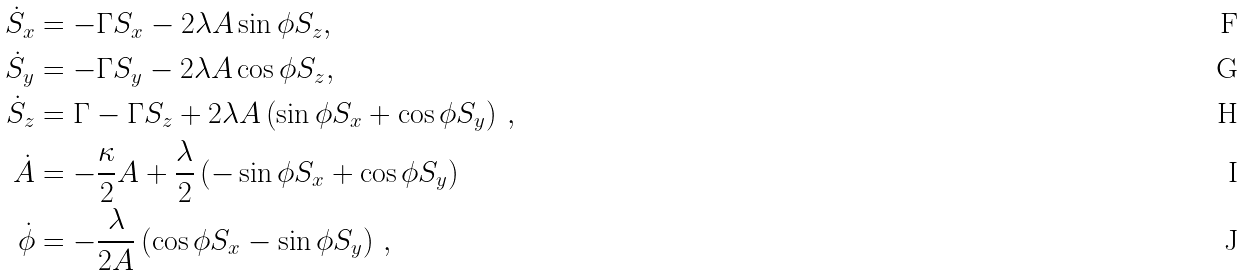<formula> <loc_0><loc_0><loc_500><loc_500>\dot { S } _ { x } & = - \Gamma S _ { x } - 2 \lambda A \sin \phi S _ { z } , \\ \dot { S } _ { y } & = - \Gamma S _ { y } - 2 \lambda A \cos \phi S _ { z } , \\ \dot { S } _ { z } & = \Gamma - \Gamma S _ { z } + 2 \lambda A \left ( \sin \phi S _ { x } + \cos \phi S _ { y } \right ) \, , \\ \dot { A } & = - \frac { \kappa } { 2 } A + \frac { \lambda } { 2 } \left ( - \sin \phi S _ { x } + \cos \phi S _ { y } \right ) \\ \dot { \phi } & = - \frac { \lambda } { 2 A } \left ( \cos \phi S _ { x } - \sin \phi S _ { y } \right ) \, ,</formula> 